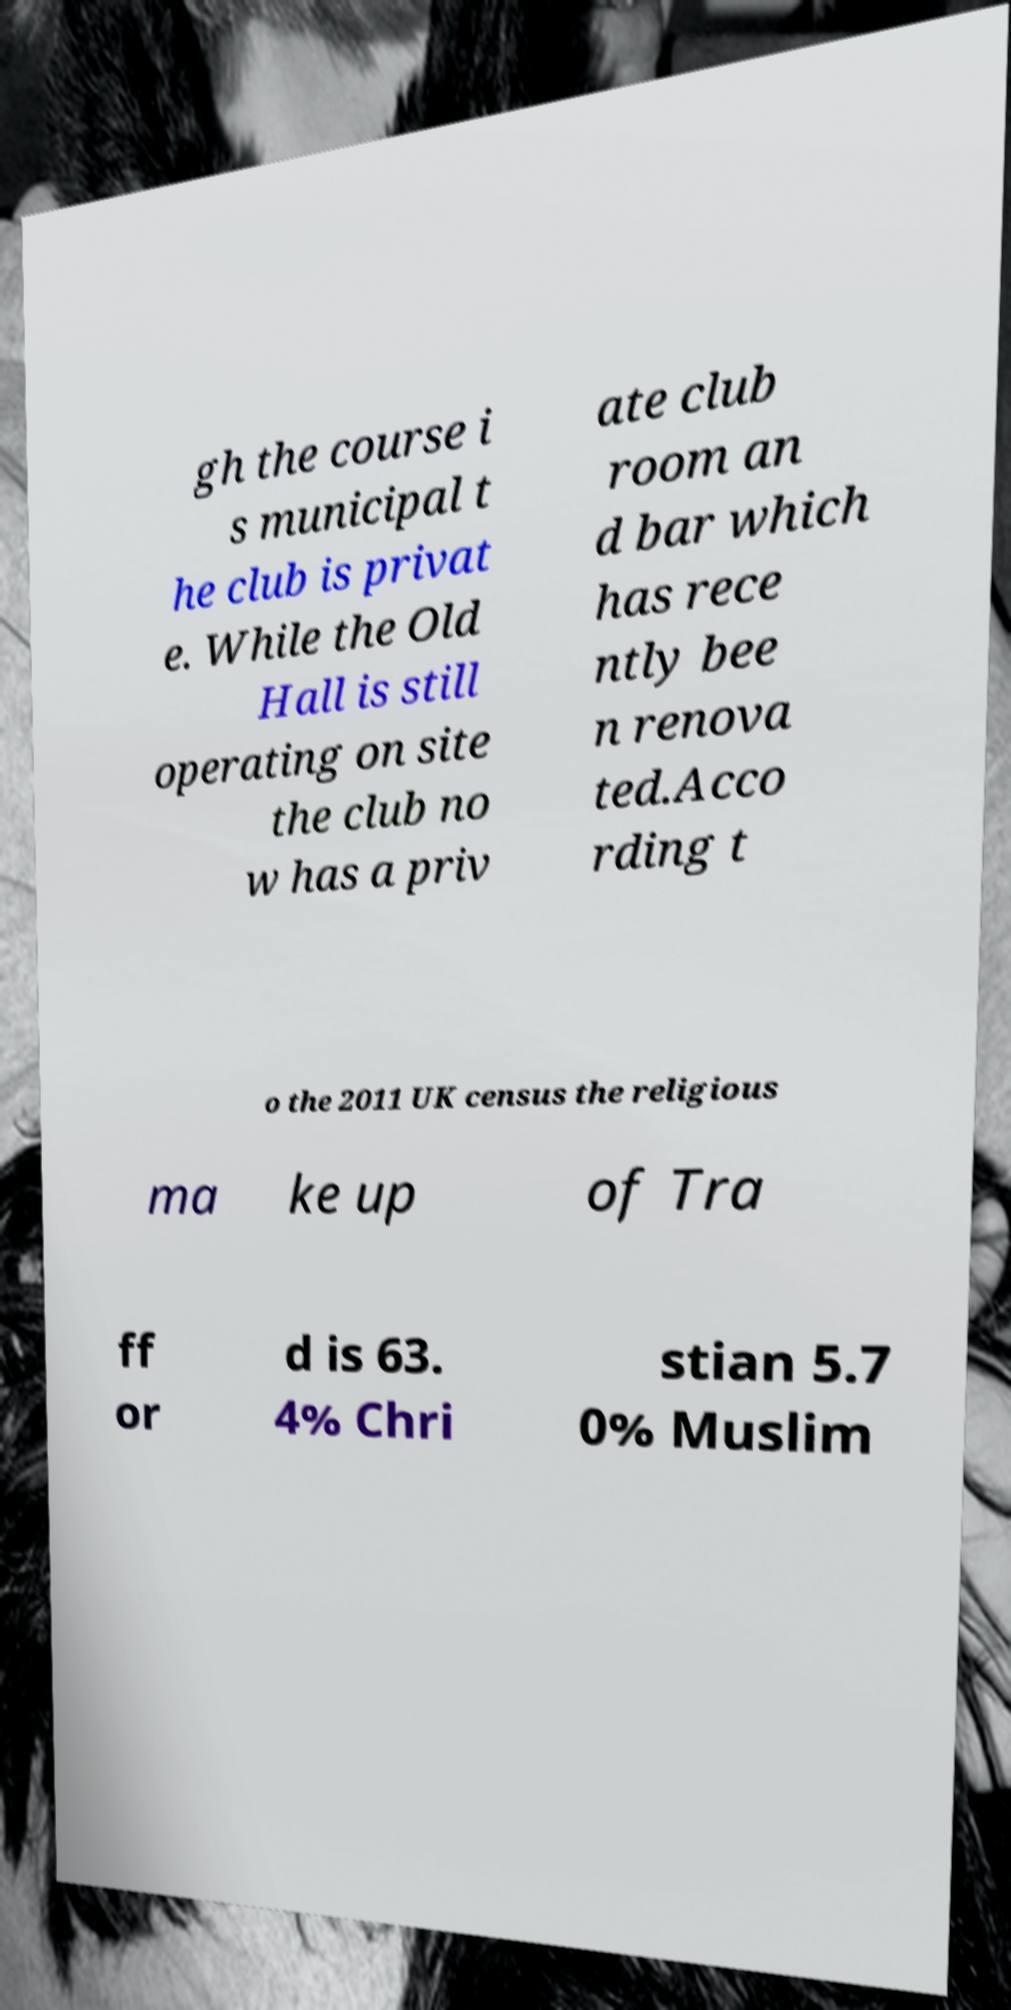Can you read and provide the text displayed in the image?This photo seems to have some interesting text. Can you extract and type it out for me? gh the course i s municipal t he club is privat e. While the Old Hall is still operating on site the club no w has a priv ate club room an d bar which has rece ntly bee n renova ted.Acco rding t o the 2011 UK census the religious ma ke up of Tra ff or d is 63. 4% Chri stian 5.7 0% Muslim 